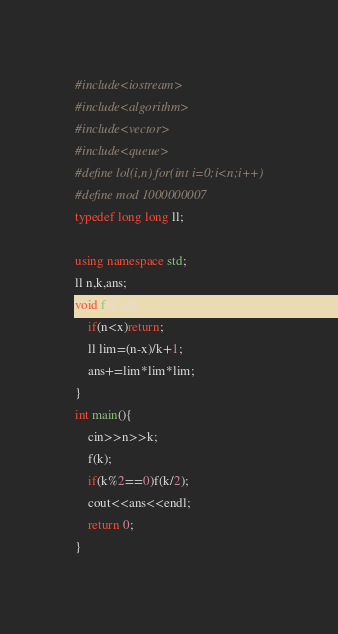<code> <loc_0><loc_0><loc_500><loc_500><_C++_>#include<iostream>
#include<algorithm>
#include<vector>
#include<queue>
#define lol(i,n) for(int i=0;i<n;i++)
#define mod 1000000007
typedef long long ll;

using namespace std;
ll n,k,ans;
void f(ll x){
    if(n<x)return;
    ll lim=(n-x)/k+1;
    ans+=lim*lim*lim;
}
int main(){
    cin>>n>>k;
    f(k);
    if(k%2==0)f(k/2);
    cout<<ans<<endl;
    return 0;
}
</code> 